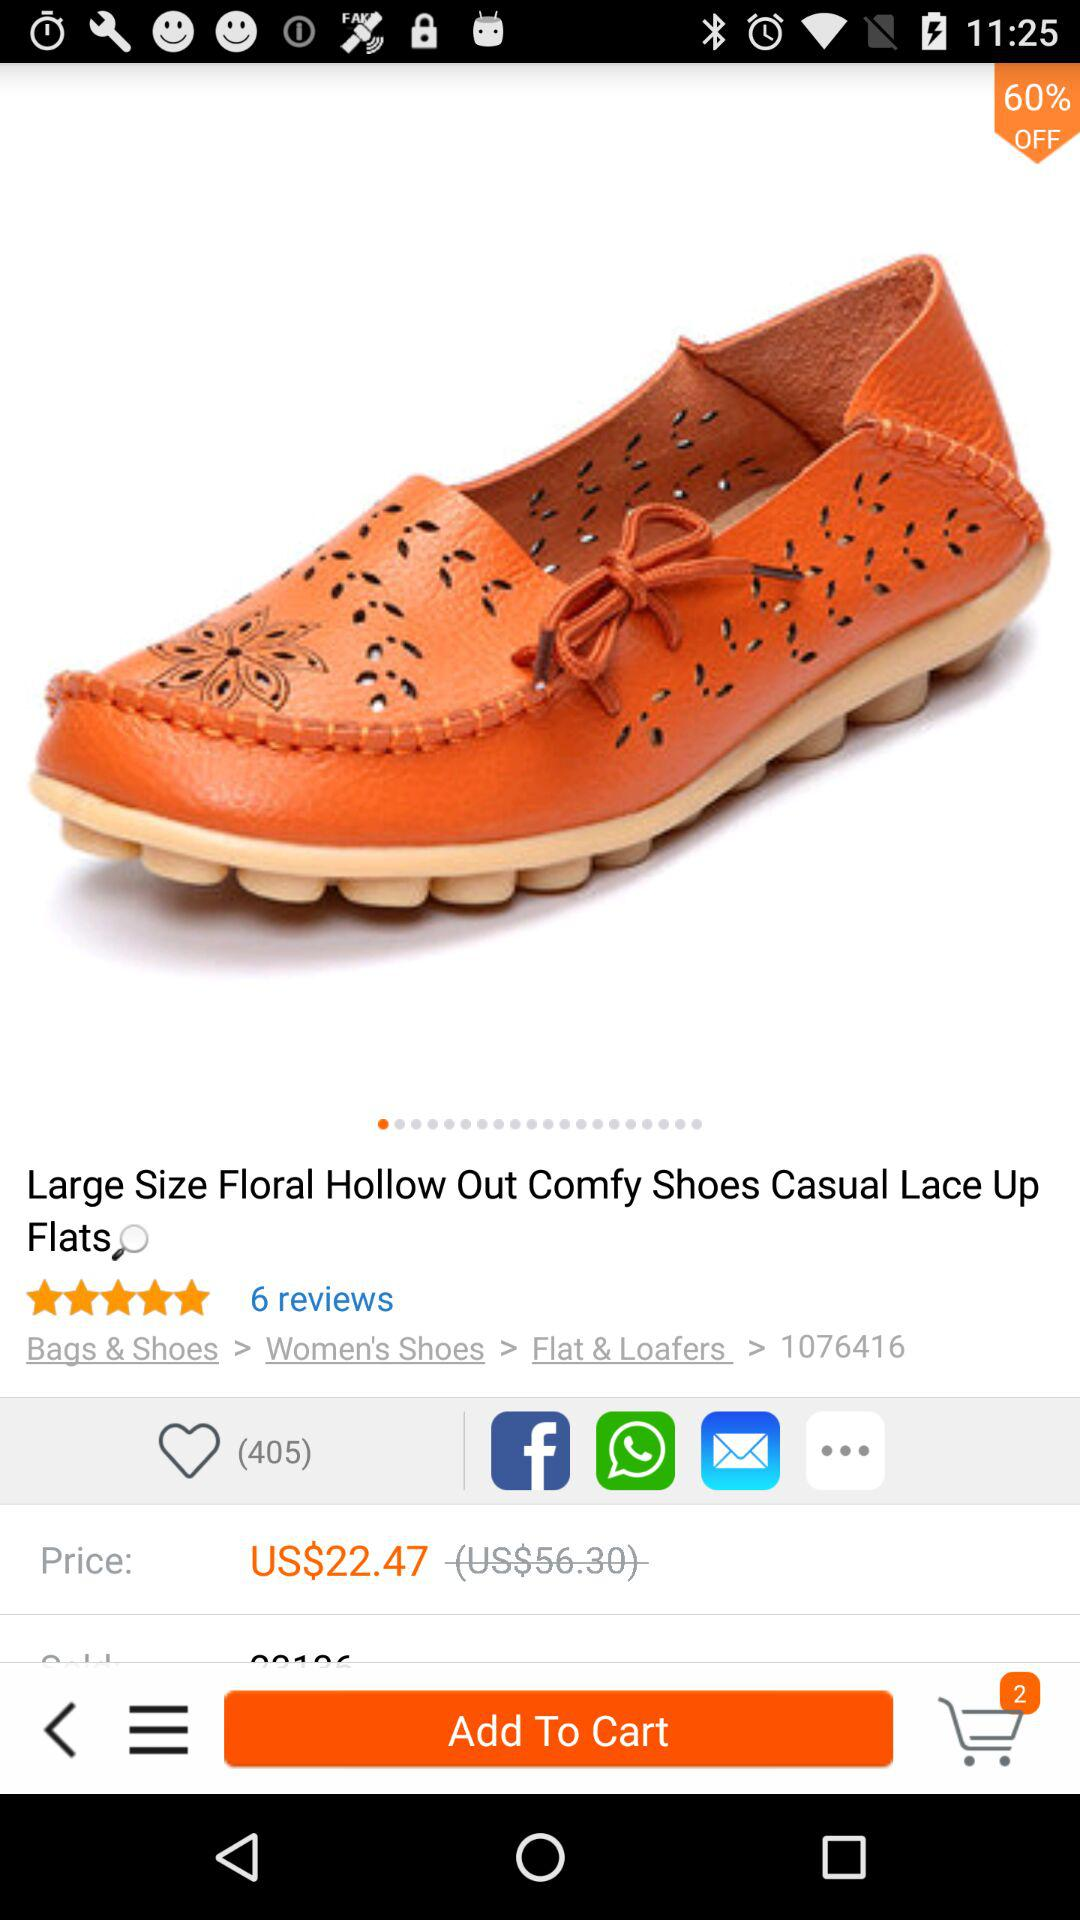How many items are in the cart? There are 2 items in the cart. 